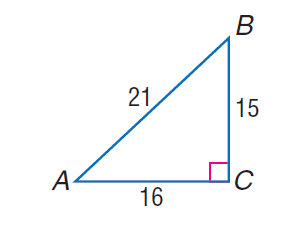Answer the mathemtical geometry problem and directly provide the correct option letter.
Question: find \tan A.
Choices: A: \frac { 15 } { 21 } B: \frac { 16 } { 21 } C: \frac { 15 } { 16 } D: \frac { 16 } { 15 } C 